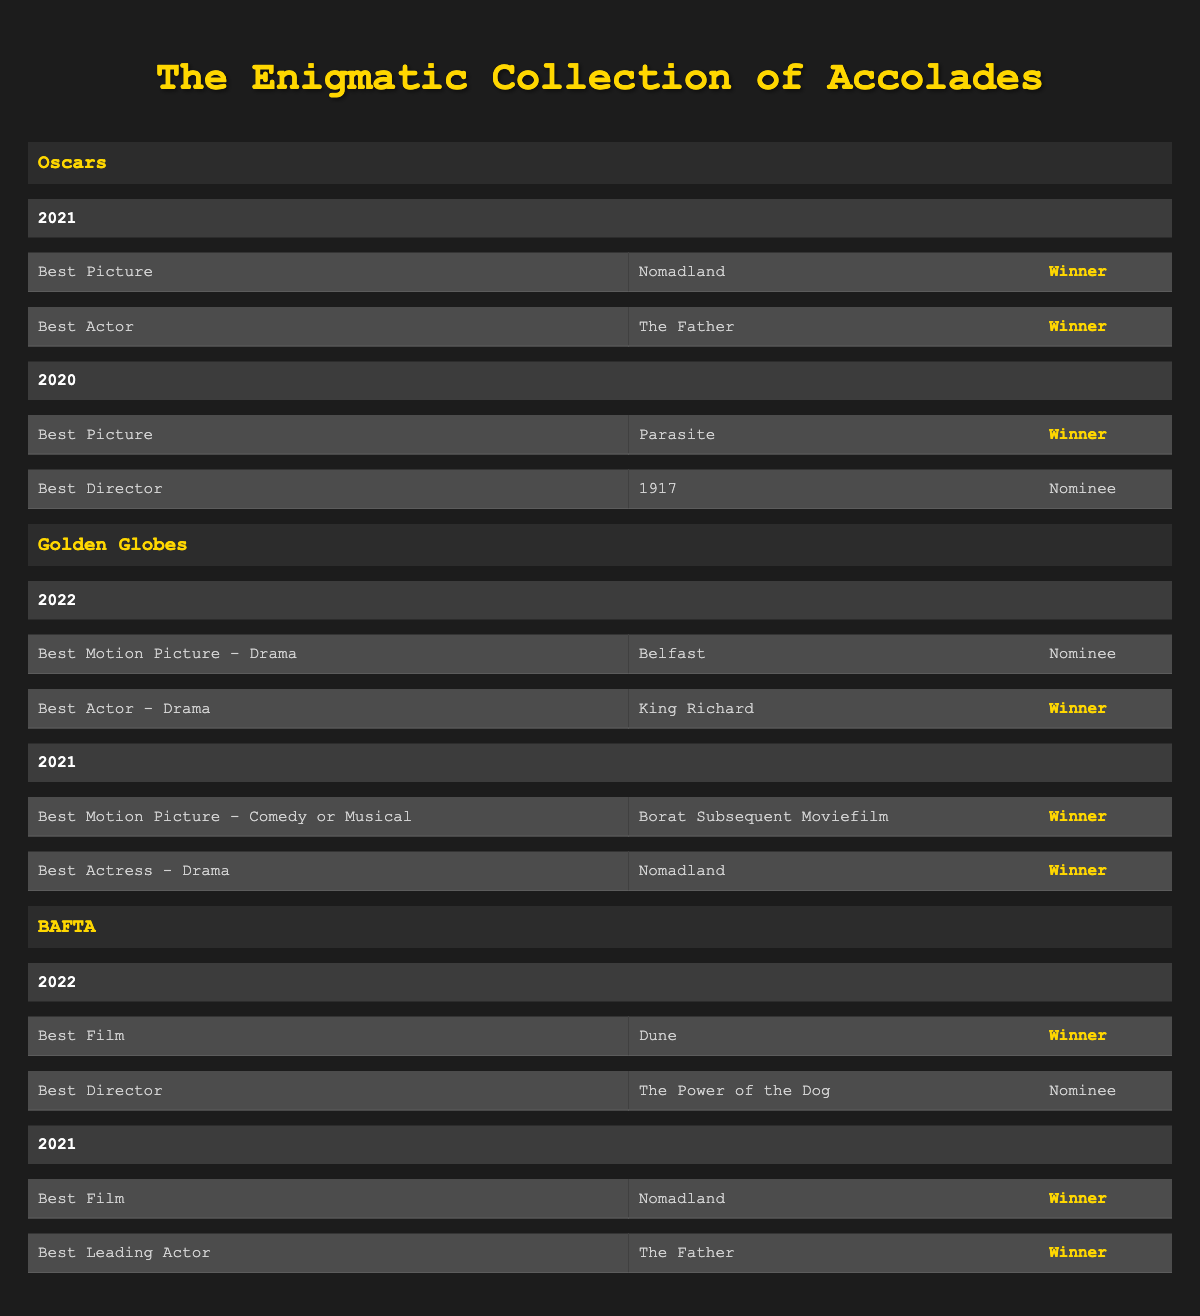What film won the Best Picture Oscar in 2021? Looking in the Oscars section under the year 2021, the entry for Best Picture shows that "Nomadland" won.
Answer: Nomadland Which film received the Best Actor award at the Oscars in 2021? In the Oscars category for 2021, the award for Best Actor was given to "The Father", featuring Anthony Hopkins.
Answer: The Father Did the film "Parasite" win the Best Picture Oscar in 2020? Checking the Oscars for 2020, "Parasite" is listed under the Best Picture category and is noted as the winner.
Answer: Yes Which film won the Best Motion Picture - Comedy or Musical Golden Globe in 2021? The Golden Globes section for 2021 lists "Borat Subsequent Moviefilm" as the winner in the Best Motion Picture - Comedy or Musical category.
Answer: Borat Subsequent Moviefilm How many films won awards at the BAFTAs in 2022? In 2022, there were two entries within the BAFTA section. "Dune" won Best Film, and "The Power of the Dog" was a nominee in the Best Director category. So, one film won an award.
Answer: 1 Was "King Richard" nominated for a Golden Globe in 2022? The entry for the Best Actor - Drama category in 2022 shows that "King Richard" was indeed the winner, which implies it was nominated.
Answer: Yes What is the total number of awards won by "Nomadland"? "Nomadland" won the Best Picture Oscar in 2021, Best Actress - Drama at the Golden Globes in 2021, and Best Film at the BAFTA in 2021. This sums up to three awards.
Answer: 3 Which film had two wins at the BAFTAs in 2021? Under the BAFTA section for 2021, both entries indicate that "Nomadland" (Best Film) and "The Father" (Best Leading Actor) won awards. No single film won two different awards; instead, two different films had wins.
Answer: None How does the number of wins for "The Father" compare between the Oscars and BAFTAs? "The Father" has one win at the Oscars (Best Actor) and one win at the BAFTAs (Best Leading Actor). Thus, it is equal in terms of wins across both award shows.
Answer: Equal 